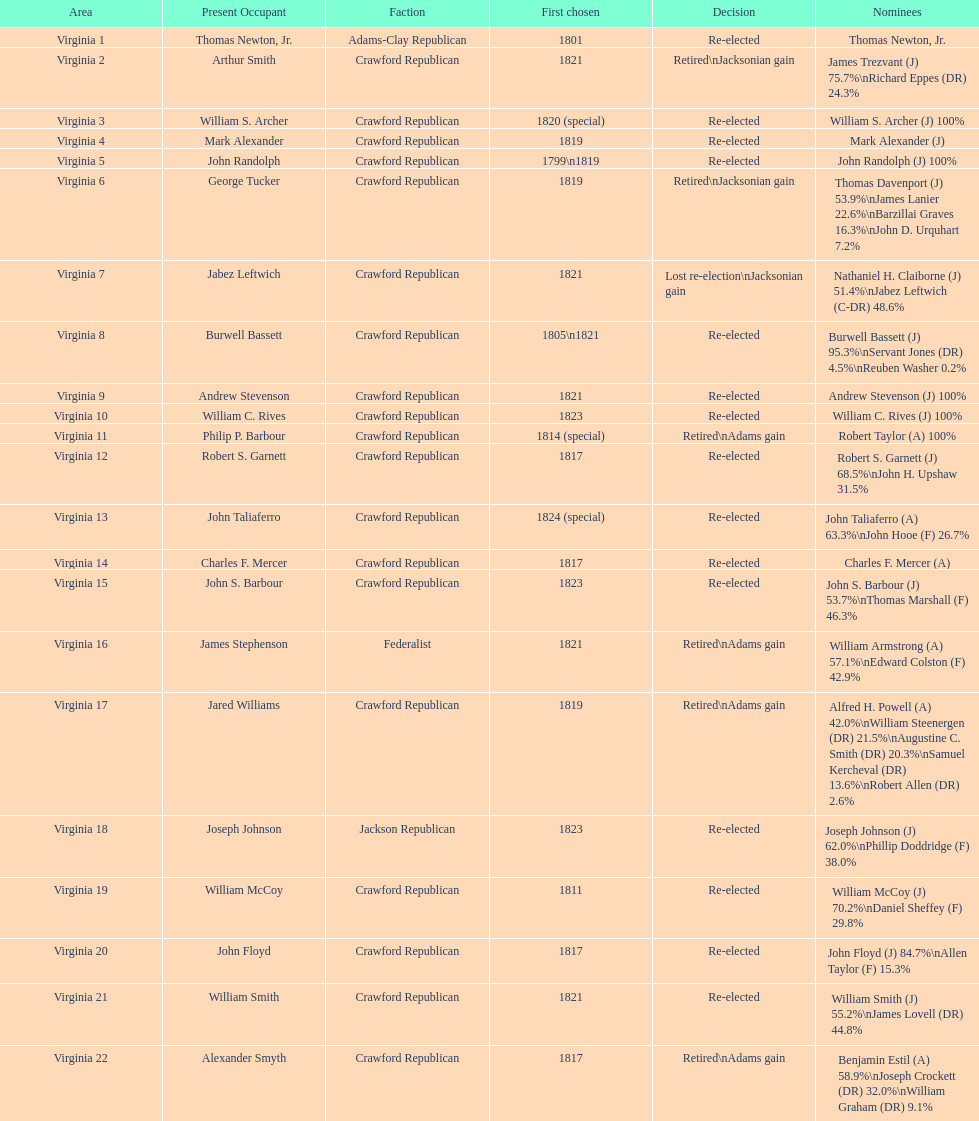What are the number of times re-elected is listed as the result? 15. 